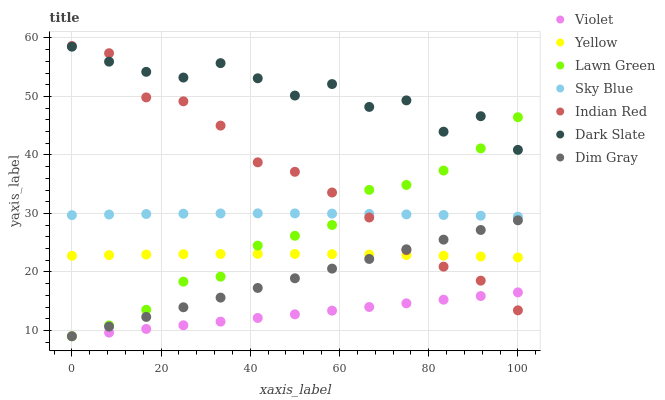Does Violet have the minimum area under the curve?
Answer yes or no. Yes. Does Dark Slate have the maximum area under the curve?
Answer yes or no. Yes. Does Dim Gray have the minimum area under the curve?
Answer yes or no. No. Does Dim Gray have the maximum area under the curve?
Answer yes or no. No. Is Dim Gray the smoothest?
Answer yes or no. Yes. Is Dark Slate the roughest?
Answer yes or no. Yes. Is Yellow the smoothest?
Answer yes or no. No. Is Yellow the roughest?
Answer yes or no. No. Does Lawn Green have the lowest value?
Answer yes or no. Yes. Does Yellow have the lowest value?
Answer yes or no. No. Does Indian Red have the highest value?
Answer yes or no. Yes. Does Dim Gray have the highest value?
Answer yes or no. No. Is Sky Blue less than Dark Slate?
Answer yes or no. Yes. Is Sky Blue greater than Violet?
Answer yes or no. Yes. Does Lawn Green intersect Yellow?
Answer yes or no. Yes. Is Lawn Green less than Yellow?
Answer yes or no. No. Is Lawn Green greater than Yellow?
Answer yes or no. No. Does Sky Blue intersect Dark Slate?
Answer yes or no. No. 